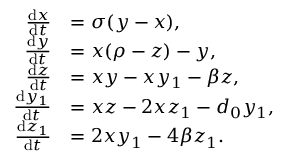Convert formula to latex. <formula><loc_0><loc_0><loc_500><loc_500>{ \begin{array} { r l } { { \frac { d x } { d t } } } & { = \sigma ( y - x ) , } \\ { { \frac { d y } { d t } } } & { = x ( \rho - z ) - y , } \\ { { \frac { d z } { d t } } } & { = x y - x y _ { 1 } - \beta z , } \\ { { \frac { d y _ { 1 } } { d t } } } & { = x z - 2 x z _ { 1 } - d _ { 0 } y _ { 1 } , } \\ { { \frac { d z _ { 1 } } { d t } } } & { = 2 x y _ { 1 } - 4 \beta z _ { 1 } . } \end{array} }</formula> 